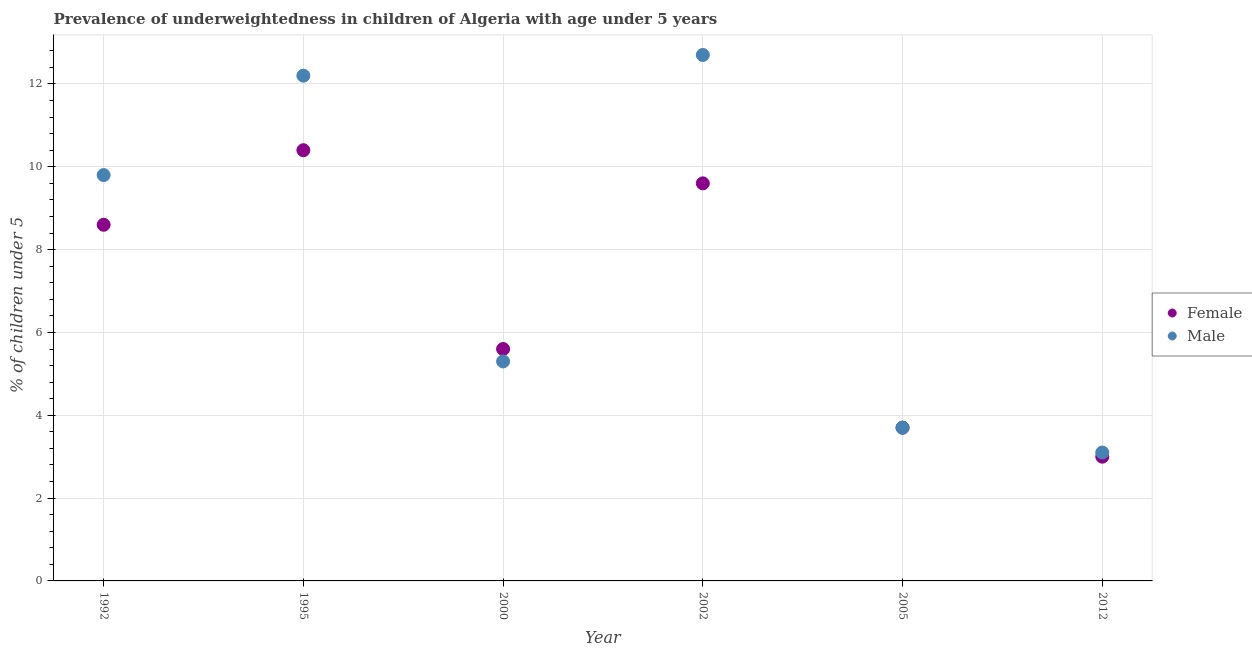How many different coloured dotlines are there?
Keep it short and to the point. 2. What is the percentage of underweighted female children in 2002?
Give a very brief answer. 9.6. Across all years, what is the maximum percentage of underweighted male children?
Provide a short and direct response. 12.7. Across all years, what is the minimum percentage of underweighted female children?
Ensure brevity in your answer.  3. In which year was the percentage of underweighted female children minimum?
Provide a short and direct response. 2012. What is the total percentage of underweighted female children in the graph?
Offer a terse response. 40.9. What is the difference between the percentage of underweighted male children in 1995 and that in 2005?
Provide a short and direct response. 8.5. What is the difference between the percentage of underweighted male children in 2002 and the percentage of underweighted female children in 1995?
Your answer should be compact. 2.3. What is the average percentage of underweighted male children per year?
Keep it short and to the point. 7.8. In how many years, is the percentage of underweighted male children greater than 2.8 %?
Provide a short and direct response. 6. What is the ratio of the percentage of underweighted male children in 1992 to that in 2002?
Provide a short and direct response. 0.77. Is the percentage of underweighted male children in 1995 less than that in 2000?
Give a very brief answer. No. What is the difference between the highest and the second highest percentage of underweighted female children?
Make the answer very short. 0.8. What is the difference between the highest and the lowest percentage of underweighted female children?
Make the answer very short. 7.4. In how many years, is the percentage of underweighted male children greater than the average percentage of underweighted male children taken over all years?
Make the answer very short. 3. Is the sum of the percentage of underweighted female children in 2000 and 2005 greater than the maximum percentage of underweighted male children across all years?
Ensure brevity in your answer.  No. Does the percentage of underweighted male children monotonically increase over the years?
Offer a very short reply. No. Is the percentage of underweighted male children strictly greater than the percentage of underweighted female children over the years?
Your answer should be compact. No. Is the percentage of underweighted male children strictly less than the percentage of underweighted female children over the years?
Give a very brief answer. No. How many years are there in the graph?
Your response must be concise. 6. What is the difference between two consecutive major ticks on the Y-axis?
Ensure brevity in your answer.  2. Are the values on the major ticks of Y-axis written in scientific E-notation?
Provide a short and direct response. No. Does the graph contain any zero values?
Your answer should be compact. No. Where does the legend appear in the graph?
Offer a very short reply. Center right. How many legend labels are there?
Offer a terse response. 2. What is the title of the graph?
Your answer should be very brief. Prevalence of underweightedness in children of Algeria with age under 5 years. What is the label or title of the Y-axis?
Give a very brief answer.  % of children under 5. What is the  % of children under 5 of Female in 1992?
Provide a succinct answer. 8.6. What is the  % of children under 5 in Male in 1992?
Make the answer very short. 9.8. What is the  % of children under 5 of Female in 1995?
Keep it short and to the point. 10.4. What is the  % of children under 5 in Male in 1995?
Make the answer very short. 12.2. What is the  % of children under 5 of Female in 2000?
Keep it short and to the point. 5.6. What is the  % of children under 5 in Male in 2000?
Provide a succinct answer. 5.3. What is the  % of children under 5 of Female in 2002?
Make the answer very short. 9.6. What is the  % of children under 5 of Male in 2002?
Offer a very short reply. 12.7. What is the  % of children under 5 in Female in 2005?
Provide a short and direct response. 3.7. What is the  % of children under 5 in Male in 2005?
Provide a succinct answer. 3.7. What is the  % of children under 5 of Female in 2012?
Provide a short and direct response. 3. What is the  % of children under 5 of Male in 2012?
Offer a very short reply. 3.1. Across all years, what is the maximum  % of children under 5 in Female?
Ensure brevity in your answer.  10.4. Across all years, what is the maximum  % of children under 5 of Male?
Offer a terse response. 12.7. Across all years, what is the minimum  % of children under 5 of Female?
Ensure brevity in your answer.  3. Across all years, what is the minimum  % of children under 5 in Male?
Provide a short and direct response. 3.1. What is the total  % of children under 5 in Female in the graph?
Provide a succinct answer. 40.9. What is the total  % of children under 5 in Male in the graph?
Your response must be concise. 46.8. What is the difference between the  % of children under 5 of Female in 1992 and that in 1995?
Your answer should be very brief. -1.8. What is the difference between the  % of children under 5 of Female in 1992 and that in 2000?
Ensure brevity in your answer.  3. What is the difference between the  % of children under 5 of Male in 1992 and that in 2002?
Your response must be concise. -2.9. What is the difference between the  % of children under 5 in Female in 1992 and that in 2012?
Your answer should be compact. 5.6. What is the difference between the  % of children under 5 of Male in 1995 and that in 2000?
Provide a succinct answer. 6.9. What is the difference between the  % of children under 5 in Female in 1995 and that in 2002?
Offer a terse response. 0.8. What is the difference between the  % of children under 5 of Female in 1995 and that in 2005?
Ensure brevity in your answer.  6.7. What is the difference between the  % of children under 5 of Male in 1995 and that in 2012?
Provide a short and direct response. 9.1. What is the difference between the  % of children under 5 in Female in 2000 and that in 2002?
Your response must be concise. -4. What is the difference between the  % of children under 5 of Female in 2002 and that in 2005?
Your response must be concise. 5.9. What is the difference between the  % of children under 5 in Female in 2002 and that in 2012?
Your response must be concise. 6.6. What is the difference between the  % of children under 5 in Male in 2002 and that in 2012?
Ensure brevity in your answer.  9.6. What is the difference between the  % of children under 5 in Male in 2005 and that in 2012?
Your answer should be compact. 0.6. What is the difference between the  % of children under 5 in Female in 1992 and the  % of children under 5 in Male in 1995?
Provide a short and direct response. -3.6. What is the difference between the  % of children under 5 of Female in 1992 and the  % of children under 5 of Male in 2000?
Provide a succinct answer. 3.3. What is the difference between the  % of children under 5 of Female in 1995 and the  % of children under 5 of Male in 2012?
Make the answer very short. 7.3. What is the difference between the  % of children under 5 of Female in 2000 and the  % of children under 5 of Male in 2005?
Keep it short and to the point. 1.9. What is the difference between the  % of children under 5 of Female in 2002 and the  % of children under 5 of Male in 2005?
Provide a succinct answer. 5.9. What is the difference between the  % of children under 5 in Female in 2005 and the  % of children under 5 in Male in 2012?
Keep it short and to the point. 0.6. What is the average  % of children under 5 of Female per year?
Your answer should be compact. 6.82. In the year 1992, what is the difference between the  % of children under 5 of Female and  % of children under 5 of Male?
Make the answer very short. -1.2. In the year 2002, what is the difference between the  % of children under 5 in Female and  % of children under 5 in Male?
Provide a short and direct response. -3.1. In the year 2005, what is the difference between the  % of children under 5 of Female and  % of children under 5 of Male?
Ensure brevity in your answer.  0. What is the ratio of the  % of children under 5 of Female in 1992 to that in 1995?
Give a very brief answer. 0.83. What is the ratio of the  % of children under 5 of Male in 1992 to that in 1995?
Provide a succinct answer. 0.8. What is the ratio of the  % of children under 5 of Female in 1992 to that in 2000?
Ensure brevity in your answer.  1.54. What is the ratio of the  % of children under 5 of Male in 1992 to that in 2000?
Ensure brevity in your answer.  1.85. What is the ratio of the  % of children under 5 in Female in 1992 to that in 2002?
Provide a short and direct response. 0.9. What is the ratio of the  % of children under 5 of Male in 1992 to that in 2002?
Your answer should be compact. 0.77. What is the ratio of the  % of children under 5 of Female in 1992 to that in 2005?
Your answer should be compact. 2.32. What is the ratio of the  % of children under 5 of Male in 1992 to that in 2005?
Keep it short and to the point. 2.65. What is the ratio of the  % of children under 5 of Female in 1992 to that in 2012?
Provide a succinct answer. 2.87. What is the ratio of the  % of children under 5 in Male in 1992 to that in 2012?
Keep it short and to the point. 3.16. What is the ratio of the  % of children under 5 of Female in 1995 to that in 2000?
Offer a very short reply. 1.86. What is the ratio of the  % of children under 5 of Male in 1995 to that in 2000?
Provide a succinct answer. 2.3. What is the ratio of the  % of children under 5 in Male in 1995 to that in 2002?
Your response must be concise. 0.96. What is the ratio of the  % of children under 5 in Female in 1995 to that in 2005?
Offer a very short reply. 2.81. What is the ratio of the  % of children under 5 of Male in 1995 to that in 2005?
Ensure brevity in your answer.  3.3. What is the ratio of the  % of children under 5 of Female in 1995 to that in 2012?
Give a very brief answer. 3.47. What is the ratio of the  % of children under 5 in Male in 1995 to that in 2012?
Offer a terse response. 3.94. What is the ratio of the  % of children under 5 of Female in 2000 to that in 2002?
Keep it short and to the point. 0.58. What is the ratio of the  % of children under 5 of Male in 2000 to that in 2002?
Your answer should be very brief. 0.42. What is the ratio of the  % of children under 5 in Female in 2000 to that in 2005?
Provide a short and direct response. 1.51. What is the ratio of the  % of children under 5 in Male in 2000 to that in 2005?
Your response must be concise. 1.43. What is the ratio of the  % of children under 5 in Female in 2000 to that in 2012?
Offer a very short reply. 1.87. What is the ratio of the  % of children under 5 of Male in 2000 to that in 2012?
Provide a succinct answer. 1.71. What is the ratio of the  % of children under 5 of Female in 2002 to that in 2005?
Offer a terse response. 2.59. What is the ratio of the  % of children under 5 of Male in 2002 to that in 2005?
Ensure brevity in your answer.  3.43. What is the ratio of the  % of children under 5 in Male in 2002 to that in 2012?
Your answer should be very brief. 4.1. What is the ratio of the  % of children under 5 of Female in 2005 to that in 2012?
Provide a short and direct response. 1.23. What is the ratio of the  % of children under 5 of Male in 2005 to that in 2012?
Keep it short and to the point. 1.19. What is the difference between the highest and the second highest  % of children under 5 in Female?
Give a very brief answer. 0.8. What is the difference between the highest and the second highest  % of children under 5 of Male?
Your answer should be compact. 0.5. What is the difference between the highest and the lowest  % of children under 5 in Female?
Offer a terse response. 7.4. What is the difference between the highest and the lowest  % of children under 5 in Male?
Give a very brief answer. 9.6. 